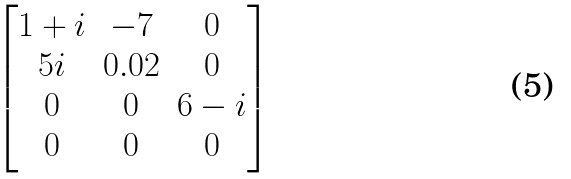Convert formula to latex. <formula><loc_0><loc_0><loc_500><loc_500>\begin{bmatrix} 1 + i & - 7 & 0 \\ 5 i & 0 . 0 2 & 0 \\ 0 & 0 & 6 - i \\ 0 & 0 & 0 \\ \end{bmatrix}</formula> 